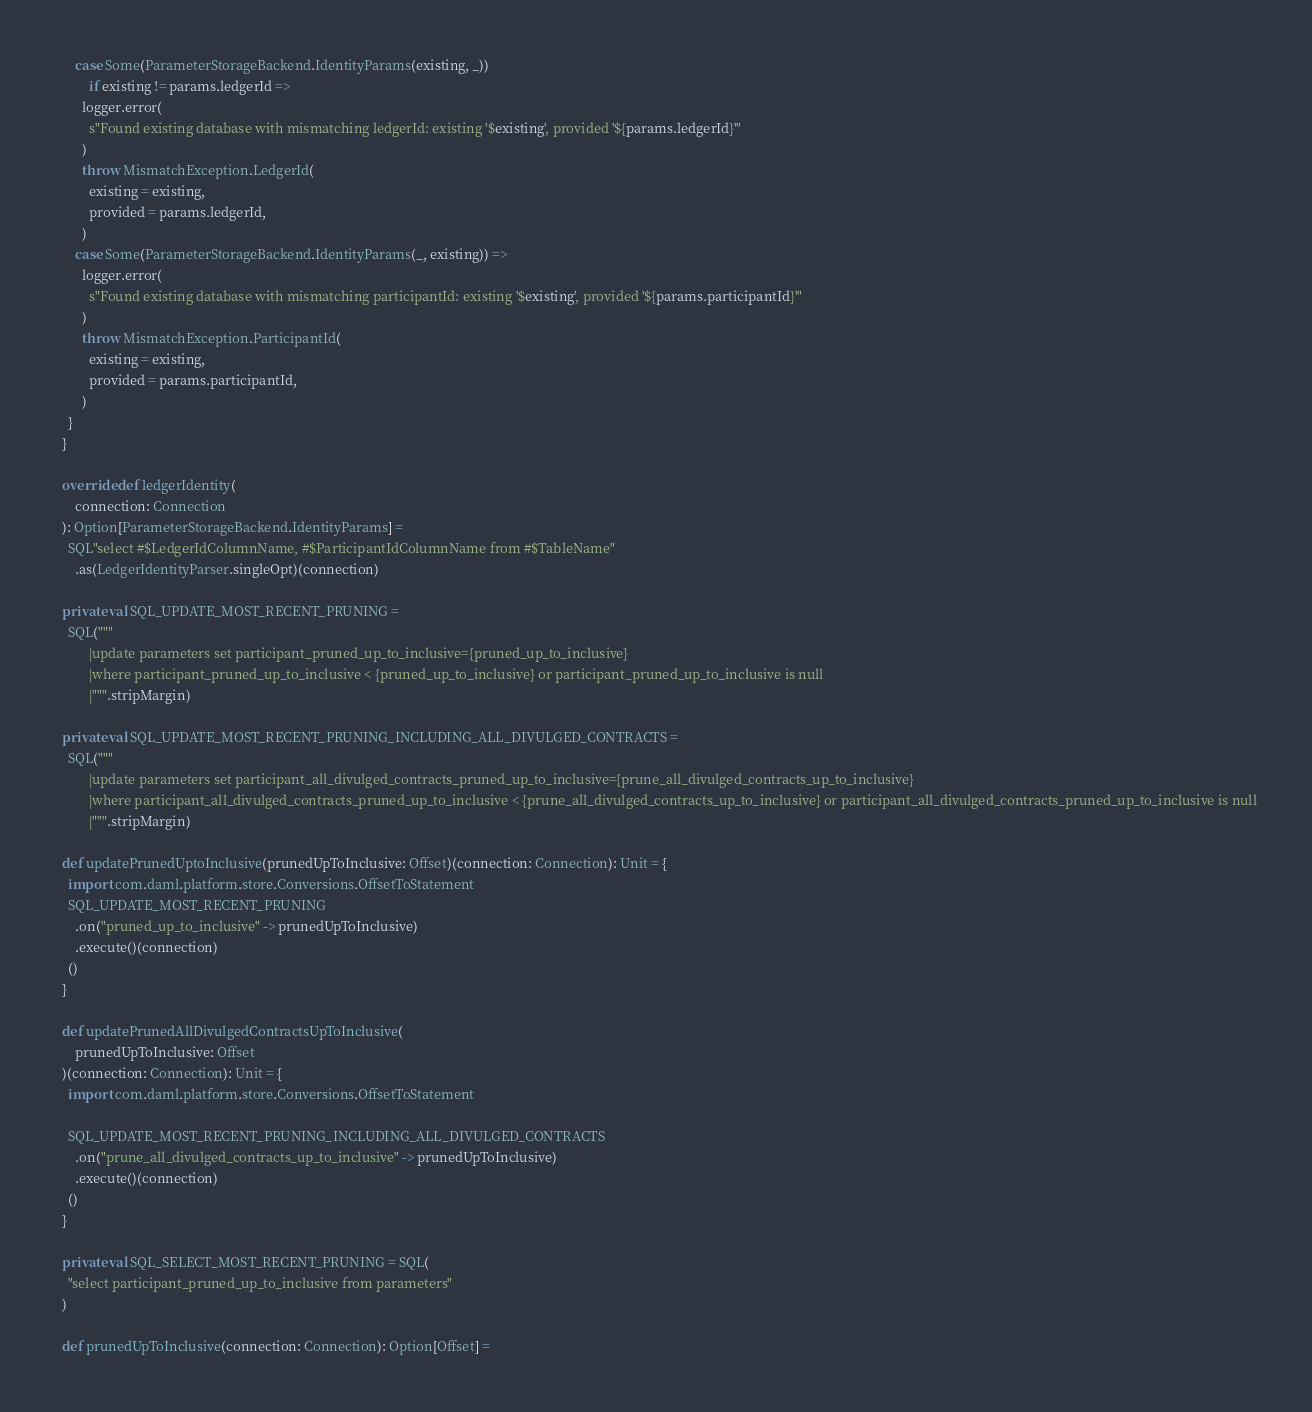<code> <loc_0><loc_0><loc_500><loc_500><_Scala_>      case Some(ParameterStorageBackend.IdentityParams(existing, _))
          if existing != params.ledgerId =>
        logger.error(
          s"Found existing database with mismatching ledgerId: existing '$existing', provided '${params.ledgerId}'"
        )
        throw MismatchException.LedgerId(
          existing = existing,
          provided = params.ledgerId,
        )
      case Some(ParameterStorageBackend.IdentityParams(_, existing)) =>
        logger.error(
          s"Found existing database with mismatching participantId: existing '$existing', provided '${params.participantId}'"
        )
        throw MismatchException.ParticipantId(
          existing = existing,
          provided = params.participantId,
        )
    }
  }

  override def ledgerIdentity(
      connection: Connection
  ): Option[ParameterStorageBackend.IdentityParams] =
    SQL"select #$LedgerIdColumnName, #$ParticipantIdColumnName from #$TableName"
      .as(LedgerIdentityParser.singleOpt)(connection)

  private val SQL_UPDATE_MOST_RECENT_PRUNING =
    SQL("""
          |update parameters set participant_pruned_up_to_inclusive={pruned_up_to_inclusive}
          |where participant_pruned_up_to_inclusive < {pruned_up_to_inclusive} or participant_pruned_up_to_inclusive is null
          |""".stripMargin)

  private val SQL_UPDATE_MOST_RECENT_PRUNING_INCLUDING_ALL_DIVULGED_CONTRACTS =
    SQL("""
          |update parameters set participant_all_divulged_contracts_pruned_up_to_inclusive={prune_all_divulged_contracts_up_to_inclusive}
          |where participant_all_divulged_contracts_pruned_up_to_inclusive < {prune_all_divulged_contracts_up_to_inclusive} or participant_all_divulged_contracts_pruned_up_to_inclusive is null
          |""".stripMargin)

  def updatePrunedUptoInclusive(prunedUpToInclusive: Offset)(connection: Connection): Unit = {
    import com.daml.platform.store.Conversions.OffsetToStatement
    SQL_UPDATE_MOST_RECENT_PRUNING
      .on("pruned_up_to_inclusive" -> prunedUpToInclusive)
      .execute()(connection)
    ()
  }

  def updatePrunedAllDivulgedContractsUpToInclusive(
      prunedUpToInclusive: Offset
  )(connection: Connection): Unit = {
    import com.daml.platform.store.Conversions.OffsetToStatement

    SQL_UPDATE_MOST_RECENT_PRUNING_INCLUDING_ALL_DIVULGED_CONTRACTS
      .on("prune_all_divulged_contracts_up_to_inclusive" -> prunedUpToInclusive)
      .execute()(connection)
    ()
  }

  private val SQL_SELECT_MOST_RECENT_PRUNING = SQL(
    "select participant_pruned_up_to_inclusive from parameters"
  )

  def prunedUpToInclusive(connection: Connection): Option[Offset] =</code> 